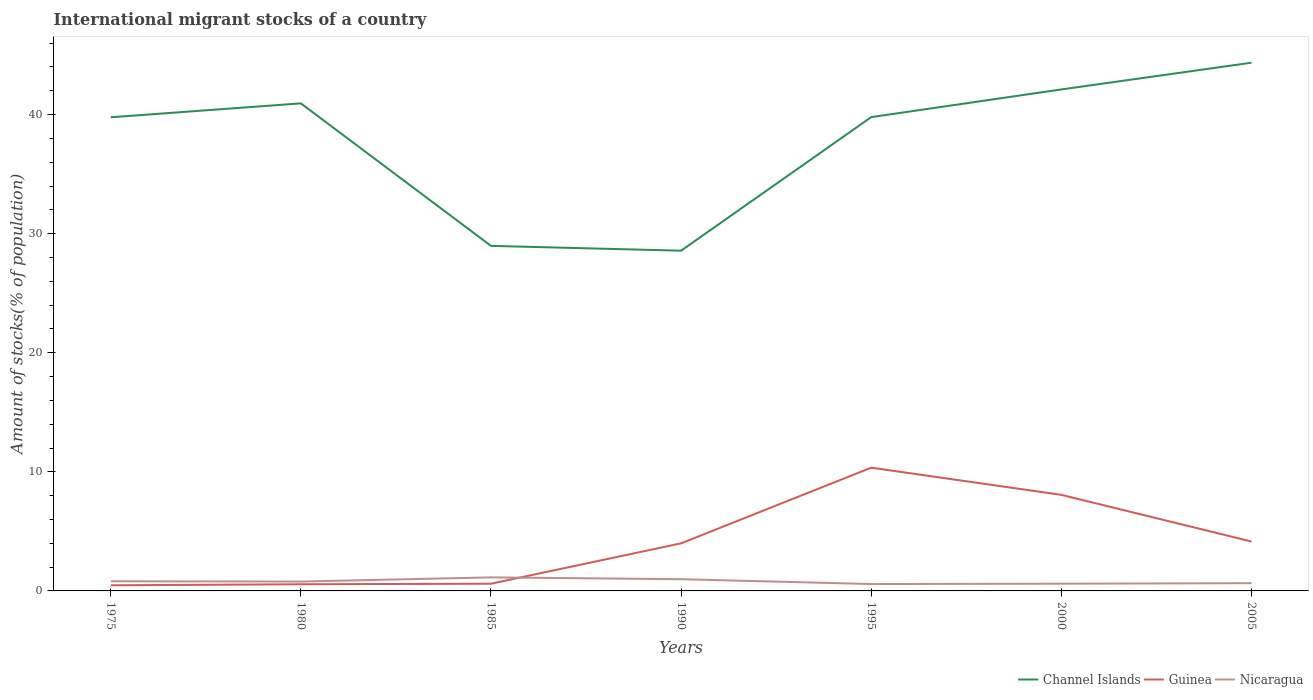Does the line corresponding to Nicaragua intersect with the line corresponding to Guinea?
Your answer should be compact. Yes. Is the number of lines equal to the number of legend labels?
Make the answer very short. Yes. Across all years, what is the maximum amount of stocks in in Nicaragua?
Your answer should be very brief. 0.58. In which year was the amount of stocks in in Guinea maximum?
Give a very brief answer. 1975. What is the total amount of stocks in in Channel Islands in the graph?
Provide a short and direct response. 10.8. What is the difference between the highest and the second highest amount of stocks in in Nicaragua?
Keep it short and to the point. 0.56. What is the difference between the highest and the lowest amount of stocks in in Nicaragua?
Provide a succinct answer. 3. Is the amount of stocks in in Channel Islands strictly greater than the amount of stocks in in Nicaragua over the years?
Your answer should be very brief. No. What is the difference between two consecutive major ticks on the Y-axis?
Provide a short and direct response. 10. Does the graph contain any zero values?
Offer a very short reply. No. Where does the legend appear in the graph?
Give a very brief answer. Bottom right. What is the title of the graph?
Your answer should be very brief. International migrant stocks of a country. Does "Timor-Leste" appear as one of the legend labels in the graph?
Your answer should be compact. No. What is the label or title of the X-axis?
Ensure brevity in your answer.  Years. What is the label or title of the Y-axis?
Your response must be concise. Amount of stocks(% of population). What is the Amount of stocks(% of population) of Channel Islands in 1975?
Offer a terse response. 39.77. What is the Amount of stocks(% of population) of Guinea in 1975?
Make the answer very short. 0.47. What is the Amount of stocks(% of population) in Nicaragua in 1975?
Offer a very short reply. 0.81. What is the Amount of stocks(% of population) in Channel Islands in 1980?
Offer a very short reply. 40.94. What is the Amount of stocks(% of population) in Guinea in 1980?
Your response must be concise. 0.56. What is the Amount of stocks(% of population) in Nicaragua in 1980?
Give a very brief answer. 0.79. What is the Amount of stocks(% of population) of Channel Islands in 1985?
Your answer should be compact. 28.98. What is the Amount of stocks(% of population) of Guinea in 1985?
Provide a succinct answer. 0.61. What is the Amount of stocks(% of population) of Nicaragua in 1985?
Offer a very short reply. 1.14. What is the Amount of stocks(% of population) of Channel Islands in 1990?
Offer a very short reply. 28.57. What is the Amount of stocks(% of population) in Guinea in 1990?
Your answer should be compact. 4. What is the Amount of stocks(% of population) of Nicaragua in 1990?
Provide a short and direct response. 0.98. What is the Amount of stocks(% of population) of Channel Islands in 1995?
Offer a terse response. 39.79. What is the Amount of stocks(% of population) in Guinea in 1995?
Your answer should be compact. 10.35. What is the Amount of stocks(% of population) of Nicaragua in 1995?
Make the answer very short. 0.58. What is the Amount of stocks(% of population) in Channel Islands in 2000?
Offer a terse response. 42.11. What is the Amount of stocks(% of population) in Guinea in 2000?
Give a very brief answer. 8.07. What is the Amount of stocks(% of population) of Nicaragua in 2000?
Ensure brevity in your answer.  0.61. What is the Amount of stocks(% of population) in Channel Islands in 2005?
Make the answer very short. 44.36. What is the Amount of stocks(% of population) in Guinea in 2005?
Make the answer very short. 4.15. What is the Amount of stocks(% of population) in Nicaragua in 2005?
Provide a short and direct response. 0.65. Across all years, what is the maximum Amount of stocks(% of population) of Channel Islands?
Keep it short and to the point. 44.36. Across all years, what is the maximum Amount of stocks(% of population) in Guinea?
Your answer should be compact. 10.35. Across all years, what is the maximum Amount of stocks(% of population) of Nicaragua?
Ensure brevity in your answer.  1.14. Across all years, what is the minimum Amount of stocks(% of population) of Channel Islands?
Keep it short and to the point. 28.57. Across all years, what is the minimum Amount of stocks(% of population) of Guinea?
Offer a very short reply. 0.47. Across all years, what is the minimum Amount of stocks(% of population) of Nicaragua?
Make the answer very short. 0.58. What is the total Amount of stocks(% of population) in Channel Islands in the graph?
Your answer should be compact. 264.52. What is the total Amount of stocks(% of population) in Guinea in the graph?
Offer a terse response. 28.2. What is the total Amount of stocks(% of population) of Nicaragua in the graph?
Provide a short and direct response. 5.55. What is the difference between the Amount of stocks(% of population) in Channel Islands in 1975 and that in 1980?
Give a very brief answer. -1.17. What is the difference between the Amount of stocks(% of population) of Guinea in 1975 and that in 1980?
Ensure brevity in your answer.  -0.09. What is the difference between the Amount of stocks(% of population) in Nicaragua in 1975 and that in 1980?
Give a very brief answer. 0.03. What is the difference between the Amount of stocks(% of population) of Channel Islands in 1975 and that in 1985?
Offer a very short reply. 10.8. What is the difference between the Amount of stocks(% of population) of Guinea in 1975 and that in 1985?
Keep it short and to the point. -0.13. What is the difference between the Amount of stocks(% of population) in Nicaragua in 1975 and that in 1985?
Ensure brevity in your answer.  -0.33. What is the difference between the Amount of stocks(% of population) of Channel Islands in 1975 and that in 1990?
Your response must be concise. 11.2. What is the difference between the Amount of stocks(% of population) of Guinea in 1975 and that in 1990?
Offer a terse response. -3.52. What is the difference between the Amount of stocks(% of population) in Nicaragua in 1975 and that in 1990?
Offer a very short reply. -0.17. What is the difference between the Amount of stocks(% of population) of Channel Islands in 1975 and that in 1995?
Offer a very short reply. -0.01. What is the difference between the Amount of stocks(% of population) in Guinea in 1975 and that in 1995?
Give a very brief answer. -9.88. What is the difference between the Amount of stocks(% of population) in Nicaragua in 1975 and that in 1995?
Your response must be concise. 0.23. What is the difference between the Amount of stocks(% of population) of Channel Islands in 1975 and that in 2000?
Keep it short and to the point. -2.34. What is the difference between the Amount of stocks(% of population) of Guinea in 1975 and that in 2000?
Offer a very short reply. -7.59. What is the difference between the Amount of stocks(% of population) in Nicaragua in 1975 and that in 2000?
Give a very brief answer. 0.2. What is the difference between the Amount of stocks(% of population) in Channel Islands in 1975 and that in 2005?
Keep it short and to the point. -4.58. What is the difference between the Amount of stocks(% of population) of Guinea in 1975 and that in 2005?
Your answer should be very brief. -3.68. What is the difference between the Amount of stocks(% of population) in Nicaragua in 1975 and that in 2005?
Your answer should be compact. 0.16. What is the difference between the Amount of stocks(% of population) of Channel Islands in 1980 and that in 1985?
Your response must be concise. 11.97. What is the difference between the Amount of stocks(% of population) in Guinea in 1980 and that in 1985?
Make the answer very short. -0.05. What is the difference between the Amount of stocks(% of population) in Nicaragua in 1980 and that in 1985?
Keep it short and to the point. -0.35. What is the difference between the Amount of stocks(% of population) in Channel Islands in 1980 and that in 1990?
Keep it short and to the point. 12.37. What is the difference between the Amount of stocks(% of population) of Guinea in 1980 and that in 1990?
Your response must be concise. -3.44. What is the difference between the Amount of stocks(% of population) in Nicaragua in 1980 and that in 1990?
Offer a very short reply. -0.2. What is the difference between the Amount of stocks(% of population) of Channel Islands in 1980 and that in 1995?
Provide a succinct answer. 1.16. What is the difference between the Amount of stocks(% of population) of Guinea in 1980 and that in 1995?
Your answer should be compact. -9.79. What is the difference between the Amount of stocks(% of population) of Nicaragua in 1980 and that in 1995?
Your answer should be very brief. 0.21. What is the difference between the Amount of stocks(% of population) of Channel Islands in 1980 and that in 2000?
Your response must be concise. -1.17. What is the difference between the Amount of stocks(% of population) in Guinea in 1980 and that in 2000?
Offer a terse response. -7.51. What is the difference between the Amount of stocks(% of population) of Nicaragua in 1980 and that in 2000?
Your answer should be very brief. 0.18. What is the difference between the Amount of stocks(% of population) of Channel Islands in 1980 and that in 2005?
Keep it short and to the point. -3.41. What is the difference between the Amount of stocks(% of population) of Guinea in 1980 and that in 2005?
Provide a succinct answer. -3.59. What is the difference between the Amount of stocks(% of population) of Nicaragua in 1980 and that in 2005?
Offer a terse response. 0.14. What is the difference between the Amount of stocks(% of population) in Channel Islands in 1985 and that in 1990?
Your answer should be compact. 0.4. What is the difference between the Amount of stocks(% of population) of Guinea in 1985 and that in 1990?
Give a very brief answer. -3.39. What is the difference between the Amount of stocks(% of population) in Nicaragua in 1985 and that in 1990?
Your answer should be very brief. 0.15. What is the difference between the Amount of stocks(% of population) of Channel Islands in 1985 and that in 1995?
Your answer should be very brief. -10.81. What is the difference between the Amount of stocks(% of population) in Guinea in 1985 and that in 1995?
Offer a terse response. -9.74. What is the difference between the Amount of stocks(% of population) in Nicaragua in 1985 and that in 1995?
Your answer should be compact. 0.56. What is the difference between the Amount of stocks(% of population) of Channel Islands in 1985 and that in 2000?
Your answer should be very brief. -13.14. What is the difference between the Amount of stocks(% of population) in Guinea in 1985 and that in 2000?
Keep it short and to the point. -7.46. What is the difference between the Amount of stocks(% of population) in Nicaragua in 1985 and that in 2000?
Your response must be concise. 0.53. What is the difference between the Amount of stocks(% of population) in Channel Islands in 1985 and that in 2005?
Make the answer very short. -15.38. What is the difference between the Amount of stocks(% of population) of Guinea in 1985 and that in 2005?
Keep it short and to the point. -3.54. What is the difference between the Amount of stocks(% of population) in Nicaragua in 1985 and that in 2005?
Your answer should be compact. 0.49. What is the difference between the Amount of stocks(% of population) in Channel Islands in 1990 and that in 1995?
Keep it short and to the point. -11.22. What is the difference between the Amount of stocks(% of population) of Guinea in 1990 and that in 1995?
Provide a succinct answer. -6.35. What is the difference between the Amount of stocks(% of population) in Nicaragua in 1990 and that in 1995?
Keep it short and to the point. 0.41. What is the difference between the Amount of stocks(% of population) in Channel Islands in 1990 and that in 2000?
Offer a terse response. -13.54. What is the difference between the Amount of stocks(% of population) in Guinea in 1990 and that in 2000?
Give a very brief answer. -4.07. What is the difference between the Amount of stocks(% of population) in Nicaragua in 1990 and that in 2000?
Provide a succinct answer. 0.38. What is the difference between the Amount of stocks(% of population) of Channel Islands in 1990 and that in 2005?
Make the answer very short. -15.79. What is the difference between the Amount of stocks(% of population) in Guinea in 1990 and that in 2005?
Offer a terse response. -0.15. What is the difference between the Amount of stocks(% of population) of Nicaragua in 1990 and that in 2005?
Ensure brevity in your answer.  0.33. What is the difference between the Amount of stocks(% of population) in Channel Islands in 1995 and that in 2000?
Give a very brief answer. -2.32. What is the difference between the Amount of stocks(% of population) of Guinea in 1995 and that in 2000?
Your answer should be very brief. 2.28. What is the difference between the Amount of stocks(% of population) in Nicaragua in 1995 and that in 2000?
Ensure brevity in your answer.  -0.03. What is the difference between the Amount of stocks(% of population) in Channel Islands in 1995 and that in 2005?
Offer a terse response. -4.57. What is the difference between the Amount of stocks(% of population) of Guinea in 1995 and that in 2005?
Your response must be concise. 6.2. What is the difference between the Amount of stocks(% of population) of Nicaragua in 1995 and that in 2005?
Keep it short and to the point. -0.07. What is the difference between the Amount of stocks(% of population) of Channel Islands in 2000 and that in 2005?
Ensure brevity in your answer.  -2.25. What is the difference between the Amount of stocks(% of population) of Guinea in 2000 and that in 2005?
Keep it short and to the point. 3.92. What is the difference between the Amount of stocks(% of population) of Nicaragua in 2000 and that in 2005?
Your response must be concise. -0.04. What is the difference between the Amount of stocks(% of population) in Channel Islands in 1975 and the Amount of stocks(% of population) in Guinea in 1980?
Offer a very short reply. 39.21. What is the difference between the Amount of stocks(% of population) of Channel Islands in 1975 and the Amount of stocks(% of population) of Nicaragua in 1980?
Offer a terse response. 38.99. What is the difference between the Amount of stocks(% of population) in Guinea in 1975 and the Amount of stocks(% of population) in Nicaragua in 1980?
Keep it short and to the point. -0.31. What is the difference between the Amount of stocks(% of population) of Channel Islands in 1975 and the Amount of stocks(% of population) of Guinea in 1985?
Make the answer very short. 39.17. What is the difference between the Amount of stocks(% of population) in Channel Islands in 1975 and the Amount of stocks(% of population) in Nicaragua in 1985?
Your response must be concise. 38.64. What is the difference between the Amount of stocks(% of population) in Guinea in 1975 and the Amount of stocks(% of population) in Nicaragua in 1985?
Provide a succinct answer. -0.67. What is the difference between the Amount of stocks(% of population) in Channel Islands in 1975 and the Amount of stocks(% of population) in Guinea in 1990?
Offer a terse response. 35.78. What is the difference between the Amount of stocks(% of population) of Channel Islands in 1975 and the Amount of stocks(% of population) of Nicaragua in 1990?
Offer a very short reply. 38.79. What is the difference between the Amount of stocks(% of population) in Guinea in 1975 and the Amount of stocks(% of population) in Nicaragua in 1990?
Provide a short and direct response. -0.51. What is the difference between the Amount of stocks(% of population) of Channel Islands in 1975 and the Amount of stocks(% of population) of Guinea in 1995?
Your answer should be compact. 29.42. What is the difference between the Amount of stocks(% of population) of Channel Islands in 1975 and the Amount of stocks(% of population) of Nicaragua in 1995?
Ensure brevity in your answer.  39.2. What is the difference between the Amount of stocks(% of population) of Guinea in 1975 and the Amount of stocks(% of population) of Nicaragua in 1995?
Provide a succinct answer. -0.1. What is the difference between the Amount of stocks(% of population) of Channel Islands in 1975 and the Amount of stocks(% of population) of Guinea in 2000?
Provide a short and direct response. 31.71. What is the difference between the Amount of stocks(% of population) in Channel Islands in 1975 and the Amount of stocks(% of population) in Nicaragua in 2000?
Ensure brevity in your answer.  39.17. What is the difference between the Amount of stocks(% of population) in Guinea in 1975 and the Amount of stocks(% of population) in Nicaragua in 2000?
Ensure brevity in your answer.  -0.13. What is the difference between the Amount of stocks(% of population) of Channel Islands in 1975 and the Amount of stocks(% of population) of Guinea in 2005?
Your answer should be very brief. 35.62. What is the difference between the Amount of stocks(% of population) in Channel Islands in 1975 and the Amount of stocks(% of population) in Nicaragua in 2005?
Provide a succinct answer. 39.12. What is the difference between the Amount of stocks(% of population) of Guinea in 1975 and the Amount of stocks(% of population) of Nicaragua in 2005?
Your response must be concise. -0.18. What is the difference between the Amount of stocks(% of population) in Channel Islands in 1980 and the Amount of stocks(% of population) in Guinea in 1985?
Keep it short and to the point. 40.34. What is the difference between the Amount of stocks(% of population) of Channel Islands in 1980 and the Amount of stocks(% of population) of Nicaragua in 1985?
Give a very brief answer. 39.8. What is the difference between the Amount of stocks(% of population) in Guinea in 1980 and the Amount of stocks(% of population) in Nicaragua in 1985?
Provide a short and direct response. -0.58. What is the difference between the Amount of stocks(% of population) of Channel Islands in 1980 and the Amount of stocks(% of population) of Guinea in 1990?
Keep it short and to the point. 36.95. What is the difference between the Amount of stocks(% of population) of Channel Islands in 1980 and the Amount of stocks(% of population) of Nicaragua in 1990?
Provide a succinct answer. 39.96. What is the difference between the Amount of stocks(% of population) in Guinea in 1980 and the Amount of stocks(% of population) in Nicaragua in 1990?
Ensure brevity in your answer.  -0.43. What is the difference between the Amount of stocks(% of population) of Channel Islands in 1980 and the Amount of stocks(% of population) of Guinea in 1995?
Make the answer very short. 30.59. What is the difference between the Amount of stocks(% of population) of Channel Islands in 1980 and the Amount of stocks(% of population) of Nicaragua in 1995?
Your answer should be compact. 40.36. What is the difference between the Amount of stocks(% of population) of Guinea in 1980 and the Amount of stocks(% of population) of Nicaragua in 1995?
Give a very brief answer. -0.02. What is the difference between the Amount of stocks(% of population) in Channel Islands in 1980 and the Amount of stocks(% of population) in Guinea in 2000?
Give a very brief answer. 32.87. What is the difference between the Amount of stocks(% of population) in Channel Islands in 1980 and the Amount of stocks(% of population) in Nicaragua in 2000?
Offer a very short reply. 40.33. What is the difference between the Amount of stocks(% of population) in Guinea in 1980 and the Amount of stocks(% of population) in Nicaragua in 2000?
Provide a succinct answer. -0.05. What is the difference between the Amount of stocks(% of population) of Channel Islands in 1980 and the Amount of stocks(% of population) of Guinea in 2005?
Your answer should be compact. 36.79. What is the difference between the Amount of stocks(% of population) in Channel Islands in 1980 and the Amount of stocks(% of population) in Nicaragua in 2005?
Offer a very short reply. 40.29. What is the difference between the Amount of stocks(% of population) of Guinea in 1980 and the Amount of stocks(% of population) of Nicaragua in 2005?
Provide a short and direct response. -0.09. What is the difference between the Amount of stocks(% of population) of Channel Islands in 1985 and the Amount of stocks(% of population) of Guinea in 1990?
Keep it short and to the point. 24.98. What is the difference between the Amount of stocks(% of population) in Channel Islands in 1985 and the Amount of stocks(% of population) in Nicaragua in 1990?
Make the answer very short. 27.99. What is the difference between the Amount of stocks(% of population) in Guinea in 1985 and the Amount of stocks(% of population) in Nicaragua in 1990?
Offer a very short reply. -0.38. What is the difference between the Amount of stocks(% of population) of Channel Islands in 1985 and the Amount of stocks(% of population) of Guinea in 1995?
Your answer should be very brief. 18.63. What is the difference between the Amount of stocks(% of population) in Channel Islands in 1985 and the Amount of stocks(% of population) in Nicaragua in 1995?
Give a very brief answer. 28.4. What is the difference between the Amount of stocks(% of population) of Guinea in 1985 and the Amount of stocks(% of population) of Nicaragua in 1995?
Your response must be concise. 0.03. What is the difference between the Amount of stocks(% of population) of Channel Islands in 1985 and the Amount of stocks(% of population) of Guinea in 2000?
Keep it short and to the point. 20.91. What is the difference between the Amount of stocks(% of population) in Channel Islands in 1985 and the Amount of stocks(% of population) in Nicaragua in 2000?
Provide a short and direct response. 28.37. What is the difference between the Amount of stocks(% of population) of Guinea in 1985 and the Amount of stocks(% of population) of Nicaragua in 2000?
Keep it short and to the point. -0. What is the difference between the Amount of stocks(% of population) of Channel Islands in 1985 and the Amount of stocks(% of population) of Guinea in 2005?
Offer a very short reply. 24.83. What is the difference between the Amount of stocks(% of population) of Channel Islands in 1985 and the Amount of stocks(% of population) of Nicaragua in 2005?
Ensure brevity in your answer.  28.33. What is the difference between the Amount of stocks(% of population) of Guinea in 1985 and the Amount of stocks(% of population) of Nicaragua in 2005?
Your answer should be very brief. -0.04. What is the difference between the Amount of stocks(% of population) of Channel Islands in 1990 and the Amount of stocks(% of population) of Guinea in 1995?
Give a very brief answer. 18.22. What is the difference between the Amount of stocks(% of population) of Channel Islands in 1990 and the Amount of stocks(% of population) of Nicaragua in 1995?
Offer a terse response. 27.99. What is the difference between the Amount of stocks(% of population) of Guinea in 1990 and the Amount of stocks(% of population) of Nicaragua in 1995?
Offer a terse response. 3.42. What is the difference between the Amount of stocks(% of population) of Channel Islands in 1990 and the Amount of stocks(% of population) of Guinea in 2000?
Offer a terse response. 20.5. What is the difference between the Amount of stocks(% of population) of Channel Islands in 1990 and the Amount of stocks(% of population) of Nicaragua in 2000?
Offer a terse response. 27.96. What is the difference between the Amount of stocks(% of population) of Guinea in 1990 and the Amount of stocks(% of population) of Nicaragua in 2000?
Ensure brevity in your answer.  3.39. What is the difference between the Amount of stocks(% of population) of Channel Islands in 1990 and the Amount of stocks(% of population) of Guinea in 2005?
Your response must be concise. 24.42. What is the difference between the Amount of stocks(% of population) of Channel Islands in 1990 and the Amount of stocks(% of population) of Nicaragua in 2005?
Give a very brief answer. 27.92. What is the difference between the Amount of stocks(% of population) in Guinea in 1990 and the Amount of stocks(% of population) in Nicaragua in 2005?
Offer a very short reply. 3.35. What is the difference between the Amount of stocks(% of population) in Channel Islands in 1995 and the Amount of stocks(% of population) in Guinea in 2000?
Your response must be concise. 31.72. What is the difference between the Amount of stocks(% of population) of Channel Islands in 1995 and the Amount of stocks(% of population) of Nicaragua in 2000?
Ensure brevity in your answer.  39.18. What is the difference between the Amount of stocks(% of population) in Guinea in 1995 and the Amount of stocks(% of population) in Nicaragua in 2000?
Provide a succinct answer. 9.74. What is the difference between the Amount of stocks(% of population) in Channel Islands in 1995 and the Amount of stocks(% of population) in Guinea in 2005?
Offer a very short reply. 35.64. What is the difference between the Amount of stocks(% of population) of Channel Islands in 1995 and the Amount of stocks(% of population) of Nicaragua in 2005?
Provide a short and direct response. 39.14. What is the difference between the Amount of stocks(% of population) of Guinea in 1995 and the Amount of stocks(% of population) of Nicaragua in 2005?
Your answer should be compact. 9.7. What is the difference between the Amount of stocks(% of population) of Channel Islands in 2000 and the Amount of stocks(% of population) of Guinea in 2005?
Your answer should be very brief. 37.96. What is the difference between the Amount of stocks(% of population) of Channel Islands in 2000 and the Amount of stocks(% of population) of Nicaragua in 2005?
Offer a terse response. 41.46. What is the difference between the Amount of stocks(% of population) of Guinea in 2000 and the Amount of stocks(% of population) of Nicaragua in 2005?
Ensure brevity in your answer.  7.42. What is the average Amount of stocks(% of population) of Channel Islands per year?
Provide a short and direct response. 37.79. What is the average Amount of stocks(% of population) in Guinea per year?
Provide a succinct answer. 4.03. What is the average Amount of stocks(% of population) of Nicaragua per year?
Your response must be concise. 0.79. In the year 1975, what is the difference between the Amount of stocks(% of population) of Channel Islands and Amount of stocks(% of population) of Guinea?
Your response must be concise. 39.3. In the year 1975, what is the difference between the Amount of stocks(% of population) of Channel Islands and Amount of stocks(% of population) of Nicaragua?
Your answer should be compact. 38.96. In the year 1975, what is the difference between the Amount of stocks(% of population) in Guinea and Amount of stocks(% of population) in Nicaragua?
Provide a succinct answer. -0.34. In the year 1980, what is the difference between the Amount of stocks(% of population) of Channel Islands and Amount of stocks(% of population) of Guinea?
Make the answer very short. 40.38. In the year 1980, what is the difference between the Amount of stocks(% of population) of Channel Islands and Amount of stocks(% of population) of Nicaragua?
Make the answer very short. 40.16. In the year 1980, what is the difference between the Amount of stocks(% of population) in Guinea and Amount of stocks(% of population) in Nicaragua?
Your answer should be very brief. -0.23. In the year 1985, what is the difference between the Amount of stocks(% of population) in Channel Islands and Amount of stocks(% of population) in Guinea?
Keep it short and to the point. 28.37. In the year 1985, what is the difference between the Amount of stocks(% of population) in Channel Islands and Amount of stocks(% of population) in Nicaragua?
Offer a very short reply. 27.84. In the year 1985, what is the difference between the Amount of stocks(% of population) in Guinea and Amount of stocks(% of population) in Nicaragua?
Provide a short and direct response. -0.53. In the year 1990, what is the difference between the Amount of stocks(% of population) of Channel Islands and Amount of stocks(% of population) of Guinea?
Ensure brevity in your answer.  24.58. In the year 1990, what is the difference between the Amount of stocks(% of population) in Channel Islands and Amount of stocks(% of population) in Nicaragua?
Your answer should be compact. 27.59. In the year 1990, what is the difference between the Amount of stocks(% of population) in Guinea and Amount of stocks(% of population) in Nicaragua?
Offer a terse response. 3.01. In the year 1995, what is the difference between the Amount of stocks(% of population) in Channel Islands and Amount of stocks(% of population) in Guinea?
Your answer should be compact. 29.44. In the year 1995, what is the difference between the Amount of stocks(% of population) of Channel Islands and Amount of stocks(% of population) of Nicaragua?
Your answer should be compact. 39.21. In the year 1995, what is the difference between the Amount of stocks(% of population) in Guinea and Amount of stocks(% of population) in Nicaragua?
Offer a very short reply. 9.77. In the year 2000, what is the difference between the Amount of stocks(% of population) in Channel Islands and Amount of stocks(% of population) in Guinea?
Give a very brief answer. 34.04. In the year 2000, what is the difference between the Amount of stocks(% of population) of Channel Islands and Amount of stocks(% of population) of Nicaragua?
Offer a very short reply. 41.5. In the year 2000, what is the difference between the Amount of stocks(% of population) of Guinea and Amount of stocks(% of population) of Nicaragua?
Offer a very short reply. 7.46. In the year 2005, what is the difference between the Amount of stocks(% of population) in Channel Islands and Amount of stocks(% of population) in Guinea?
Your answer should be compact. 40.21. In the year 2005, what is the difference between the Amount of stocks(% of population) of Channel Islands and Amount of stocks(% of population) of Nicaragua?
Give a very brief answer. 43.71. In the year 2005, what is the difference between the Amount of stocks(% of population) of Guinea and Amount of stocks(% of population) of Nicaragua?
Make the answer very short. 3.5. What is the ratio of the Amount of stocks(% of population) of Channel Islands in 1975 to that in 1980?
Your answer should be very brief. 0.97. What is the ratio of the Amount of stocks(% of population) in Guinea in 1975 to that in 1980?
Keep it short and to the point. 0.85. What is the ratio of the Amount of stocks(% of population) of Nicaragua in 1975 to that in 1980?
Give a very brief answer. 1.03. What is the ratio of the Amount of stocks(% of population) of Channel Islands in 1975 to that in 1985?
Offer a terse response. 1.37. What is the ratio of the Amount of stocks(% of population) of Guinea in 1975 to that in 1985?
Your response must be concise. 0.78. What is the ratio of the Amount of stocks(% of population) in Nicaragua in 1975 to that in 1985?
Make the answer very short. 0.71. What is the ratio of the Amount of stocks(% of population) of Channel Islands in 1975 to that in 1990?
Keep it short and to the point. 1.39. What is the ratio of the Amount of stocks(% of population) of Guinea in 1975 to that in 1990?
Your answer should be very brief. 0.12. What is the ratio of the Amount of stocks(% of population) of Nicaragua in 1975 to that in 1990?
Offer a very short reply. 0.82. What is the ratio of the Amount of stocks(% of population) of Channel Islands in 1975 to that in 1995?
Offer a very short reply. 1. What is the ratio of the Amount of stocks(% of population) in Guinea in 1975 to that in 1995?
Provide a succinct answer. 0.05. What is the ratio of the Amount of stocks(% of population) of Nicaragua in 1975 to that in 1995?
Keep it short and to the point. 1.4. What is the ratio of the Amount of stocks(% of population) of Channel Islands in 1975 to that in 2000?
Offer a very short reply. 0.94. What is the ratio of the Amount of stocks(% of population) of Guinea in 1975 to that in 2000?
Offer a very short reply. 0.06. What is the ratio of the Amount of stocks(% of population) of Nicaragua in 1975 to that in 2000?
Provide a short and direct response. 1.33. What is the ratio of the Amount of stocks(% of population) of Channel Islands in 1975 to that in 2005?
Ensure brevity in your answer.  0.9. What is the ratio of the Amount of stocks(% of population) in Guinea in 1975 to that in 2005?
Keep it short and to the point. 0.11. What is the ratio of the Amount of stocks(% of population) in Nicaragua in 1975 to that in 2005?
Make the answer very short. 1.25. What is the ratio of the Amount of stocks(% of population) in Channel Islands in 1980 to that in 1985?
Provide a short and direct response. 1.41. What is the ratio of the Amount of stocks(% of population) of Guinea in 1980 to that in 1985?
Offer a very short reply. 0.92. What is the ratio of the Amount of stocks(% of population) of Nicaragua in 1980 to that in 1985?
Keep it short and to the point. 0.69. What is the ratio of the Amount of stocks(% of population) in Channel Islands in 1980 to that in 1990?
Your response must be concise. 1.43. What is the ratio of the Amount of stocks(% of population) in Guinea in 1980 to that in 1990?
Your answer should be very brief. 0.14. What is the ratio of the Amount of stocks(% of population) in Nicaragua in 1980 to that in 1990?
Your answer should be very brief. 0.8. What is the ratio of the Amount of stocks(% of population) in Guinea in 1980 to that in 1995?
Make the answer very short. 0.05. What is the ratio of the Amount of stocks(% of population) of Nicaragua in 1980 to that in 1995?
Provide a short and direct response. 1.36. What is the ratio of the Amount of stocks(% of population) of Channel Islands in 1980 to that in 2000?
Keep it short and to the point. 0.97. What is the ratio of the Amount of stocks(% of population) of Guinea in 1980 to that in 2000?
Your answer should be compact. 0.07. What is the ratio of the Amount of stocks(% of population) in Nicaragua in 1980 to that in 2000?
Your answer should be compact. 1.29. What is the ratio of the Amount of stocks(% of population) in Channel Islands in 1980 to that in 2005?
Your answer should be compact. 0.92. What is the ratio of the Amount of stocks(% of population) of Guinea in 1980 to that in 2005?
Provide a succinct answer. 0.13. What is the ratio of the Amount of stocks(% of population) in Nicaragua in 1980 to that in 2005?
Provide a succinct answer. 1.21. What is the ratio of the Amount of stocks(% of population) of Channel Islands in 1985 to that in 1990?
Your response must be concise. 1.01. What is the ratio of the Amount of stocks(% of population) of Guinea in 1985 to that in 1990?
Ensure brevity in your answer.  0.15. What is the ratio of the Amount of stocks(% of population) of Nicaragua in 1985 to that in 1990?
Offer a terse response. 1.16. What is the ratio of the Amount of stocks(% of population) in Channel Islands in 1985 to that in 1995?
Give a very brief answer. 0.73. What is the ratio of the Amount of stocks(% of population) of Guinea in 1985 to that in 1995?
Offer a terse response. 0.06. What is the ratio of the Amount of stocks(% of population) of Nicaragua in 1985 to that in 1995?
Your response must be concise. 1.97. What is the ratio of the Amount of stocks(% of population) of Channel Islands in 1985 to that in 2000?
Make the answer very short. 0.69. What is the ratio of the Amount of stocks(% of population) in Guinea in 1985 to that in 2000?
Keep it short and to the point. 0.08. What is the ratio of the Amount of stocks(% of population) in Nicaragua in 1985 to that in 2000?
Ensure brevity in your answer.  1.87. What is the ratio of the Amount of stocks(% of population) of Channel Islands in 1985 to that in 2005?
Provide a succinct answer. 0.65. What is the ratio of the Amount of stocks(% of population) of Guinea in 1985 to that in 2005?
Provide a succinct answer. 0.15. What is the ratio of the Amount of stocks(% of population) of Nicaragua in 1985 to that in 2005?
Make the answer very short. 1.75. What is the ratio of the Amount of stocks(% of population) of Channel Islands in 1990 to that in 1995?
Your answer should be compact. 0.72. What is the ratio of the Amount of stocks(% of population) in Guinea in 1990 to that in 1995?
Your answer should be compact. 0.39. What is the ratio of the Amount of stocks(% of population) of Nicaragua in 1990 to that in 1995?
Give a very brief answer. 1.7. What is the ratio of the Amount of stocks(% of population) in Channel Islands in 1990 to that in 2000?
Make the answer very short. 0.68. What is the ratio of the Amount of stocks(% of population) in Guinea in 1990 to that in 2000?
Keep it short and to the point. 0.5. What is the ratio of the Amount of stocks(% of population) of Nicaragua in 1990 to that in 2000?
Provide a short and direct response. 1.62. What is the ratio of the Amount of stocks(% of population) in Channel Islands in 1990 to that in 2005?
Your answer should be very brief. 0.64. What is the ratio of the Amount of stocks(% of population) in Nicaragua in 1990 to that in 2005?
Give a very brief answer. 1.51. What is the ratio of the Amount of stocks(% of population) in Channel Islands in 1995 to that in 2000?
Make the answer very short. 0.94. What is the ratio of the Amount of stocks(% of population) in Guinea in 1995 to that in 2000?
Keep it short and to the point. 1.28. What is the ratio of the Amount of stocks(% of population) in Nicaragua in 1995 to that in 2000?
Ensure brevity in your answer.  0.95. What is the ratio of the Amount of stocks(% of population) of Channel Islands in 1995 to that in 2005?
Your answer should be compact. 0.9. What is the ratio of the Amount of stocks(% of population) in Guinea in 1995 to that in 2005?
Offer a terse response. 2.49. What is the ratio of the Amount of stocks(% of population) of Nicaragua in 1995 to that in 2005?
Offer a very short reply. 0.89. What is the ratio of the Amount of stocks(% of population) in Channel Islands in 2000 to that in 2005?
Keep it short and to the point. 0.95. What is the ratio of the Amount of stocks(% of population) in Guinea in 2000 to that in 2005?
Offer a terse response. 1.94. What is the ratio of the Amount of stocks(% of population) of Nicaragua in 2000 to that in 2005?
Keep it short and to the point. 0.94. What is the difference between the highest and the second highest Amount of stocks(% of population) of Channel Islands?
Provide a short and direct response. 2.25. What is the difference between the highest and the second highest Amount of stocks(% of population) of Guinea?
Provide a short and direct response. 2.28. What is the difference between the highest and the second highest Amount of stocks(% of population) of Nicaragua?
Give a very brief answer. 0.15. What is the difference between the highest and the lowest Amount of stocks(% of population) of Channel Islands?
Your answer should be compact. 15.79. What is the difference between the highest and the lowest Amount of stocks(% of population) in Guinea?
Offer a very short reply. 9.88. What is the difference between the highest and the lowest Amount of stocks(% of population) in Nicaragua?
Your answer should be compact. 0.56. 